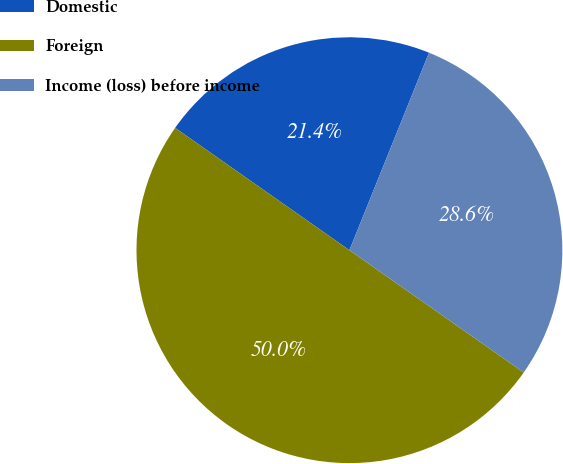<chart> <loc_0><loc_0><loc_500><loc_500><pie_chart><fcel>Domestic<fcel>Foreign<fcel>Income (loss) before income<nl><fcel>21.36%<fcel>50.0%<fcel>28.64%<nl></chart> 